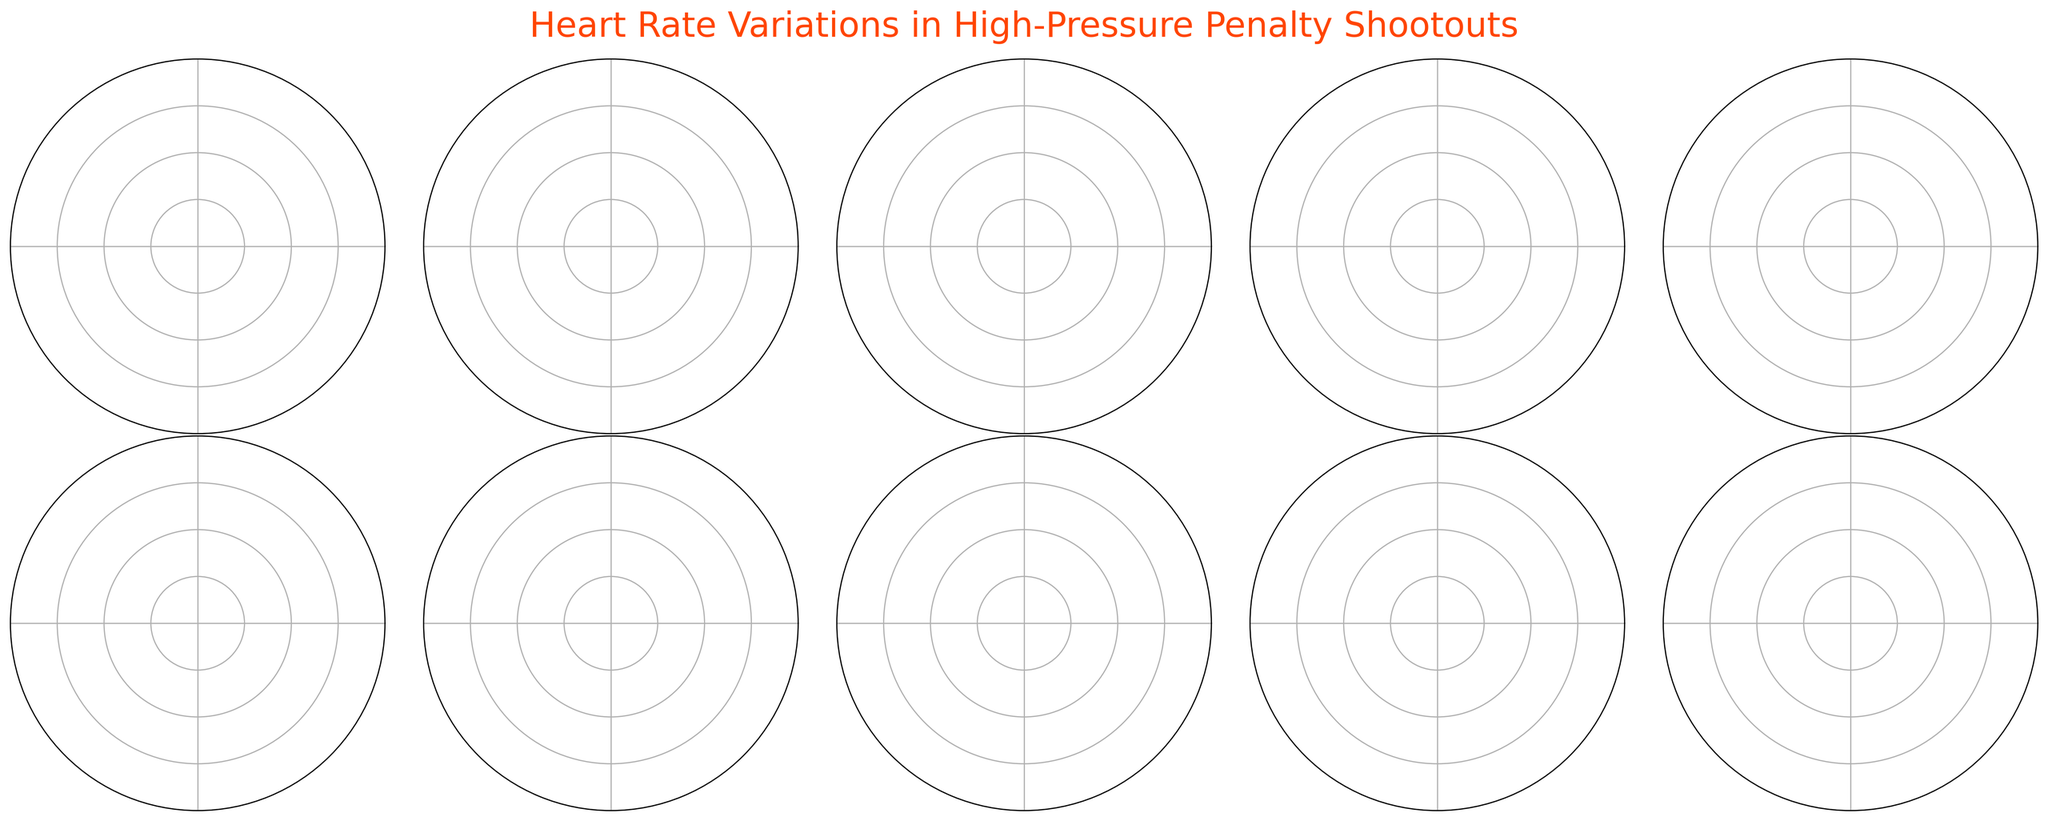Which player has the highest average heart rate during the penalty shootouts? The figure shows each player's average heart rate within the gauge chart. Kylian Mbappé's needle is the furthest to the right, indicating the highest average heart rate.
Answer: Kylian Mbappé What is the range of Lionel Messi's heart rate during the shootouts? The range can be calculated by subtracting the minimum heart rate from the maximum heart rate. For Messi, the max heart rate is 170 bpm and the min heart rate is 90 bpm. Thus, the range is 170 - 90 = 80 bpm.
Answer: 80 bpm What color indicates the player’s highest heart rate on the gauge chart? Each gauge chart shows a red circle indicating the player's highest heart rate. This is consistent across all charts.
Answer: Red Who has the smallest difference between the maximum and minimum heart rates? To identify the player, compare the ranges of each player’s heart rate. Robert Lewandowski’s max heart rate is 162 bpm and min is 82 bpm, resulting in a difference of 80 bpm, which appears to be the smallest difference among players.
Answer: Robert Lewandowski What is the average heart rate of Harry Kane during the shootouts? The needle in Harry Kane’s gauge chart points to his average heart rate. The text below his name displays "120 bpm" indicating his average heart rate.
Answer: 120 bpm Which player has the lowest maximum heart rate during the shootouts? By inspecting the red indicator on each gauge chart, Harry Kane’s highest heart rate appears to be the lowest at 160 bpm.
Answer: Harry Kane Compare the average heart rates of Lionel Messi and Cristiano Ronaldo. Who has a higher average heart rate? By examining the gauge charts, Messi's average heart rate is 130 bpm, whereas Ronaldo’s is 125 bpm. Therefore, Messi’s average heart rate is higher.
Answer: Lionel Messi What is the difference between the average heart rates of Neymar Jr. and Mohamed Salah? Neymar Jr.’s average heart rate is 128 bpm, and Mohamed Salah’s is 127 bpm. The difference is calculated as 128 - 127 = 1 bpm.
Answer: 1 bpm For which player is the average heart rate closest to 130 bpm? By comparing the average heart rates, Lionel Messi has an exact average heart rate of 130 bpm, making him the closest to 130 bpm.
Answer: Lionel Messi How many players have an average heart rate above 130 bpm during the shootouts? By examining the needle positions and their corresponding values, Kylian Mbappé, Kevin De Bruyne, Erling Haaland, and Lionel Messi have average heart rates above 130 bpm, resulting in a total of four players.
Answer: Four 